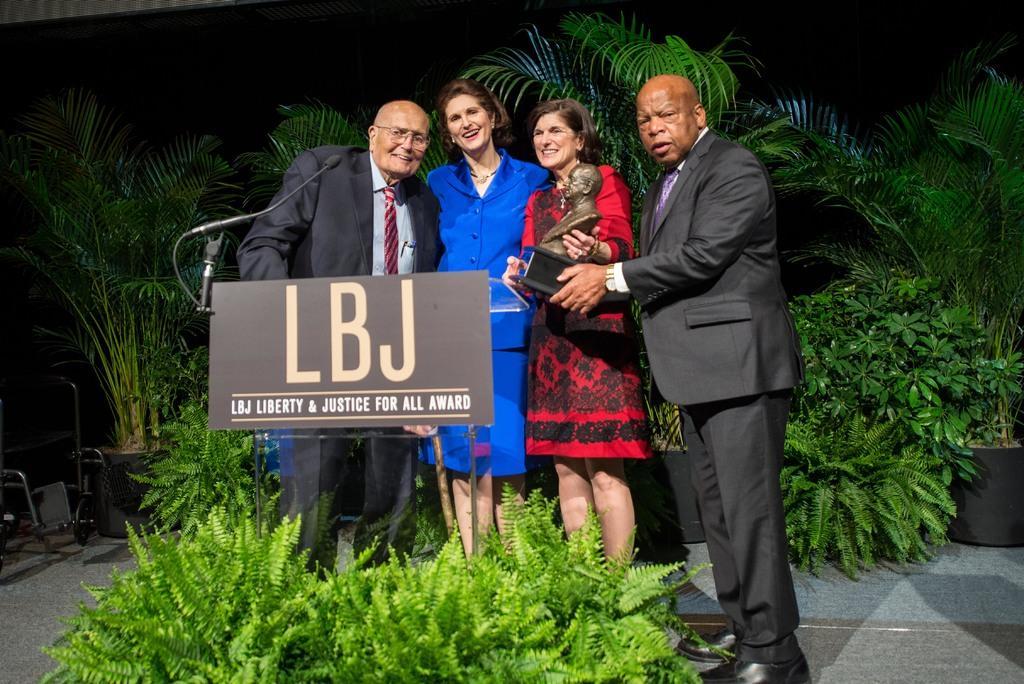Could you give a brief overview of what you see in this image? In this image I can see four persons visible in front of the board , on the board I can see a text and mike attached and I can see two persons holding sculpture and at the bottom I can see plants and back side I can see plants and flower pot and this picture is taken during night. 